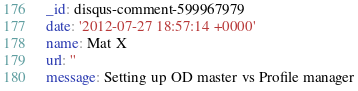<code> <loc_0><loc_0><loc_500><loc_500><_YAML_>_id: disqus-comment-599967979
date: '2012-07-27 18:57:14 +0000'
name: Mat X
url: ''
message: Setting up OD master vs Profile manager
</code> 